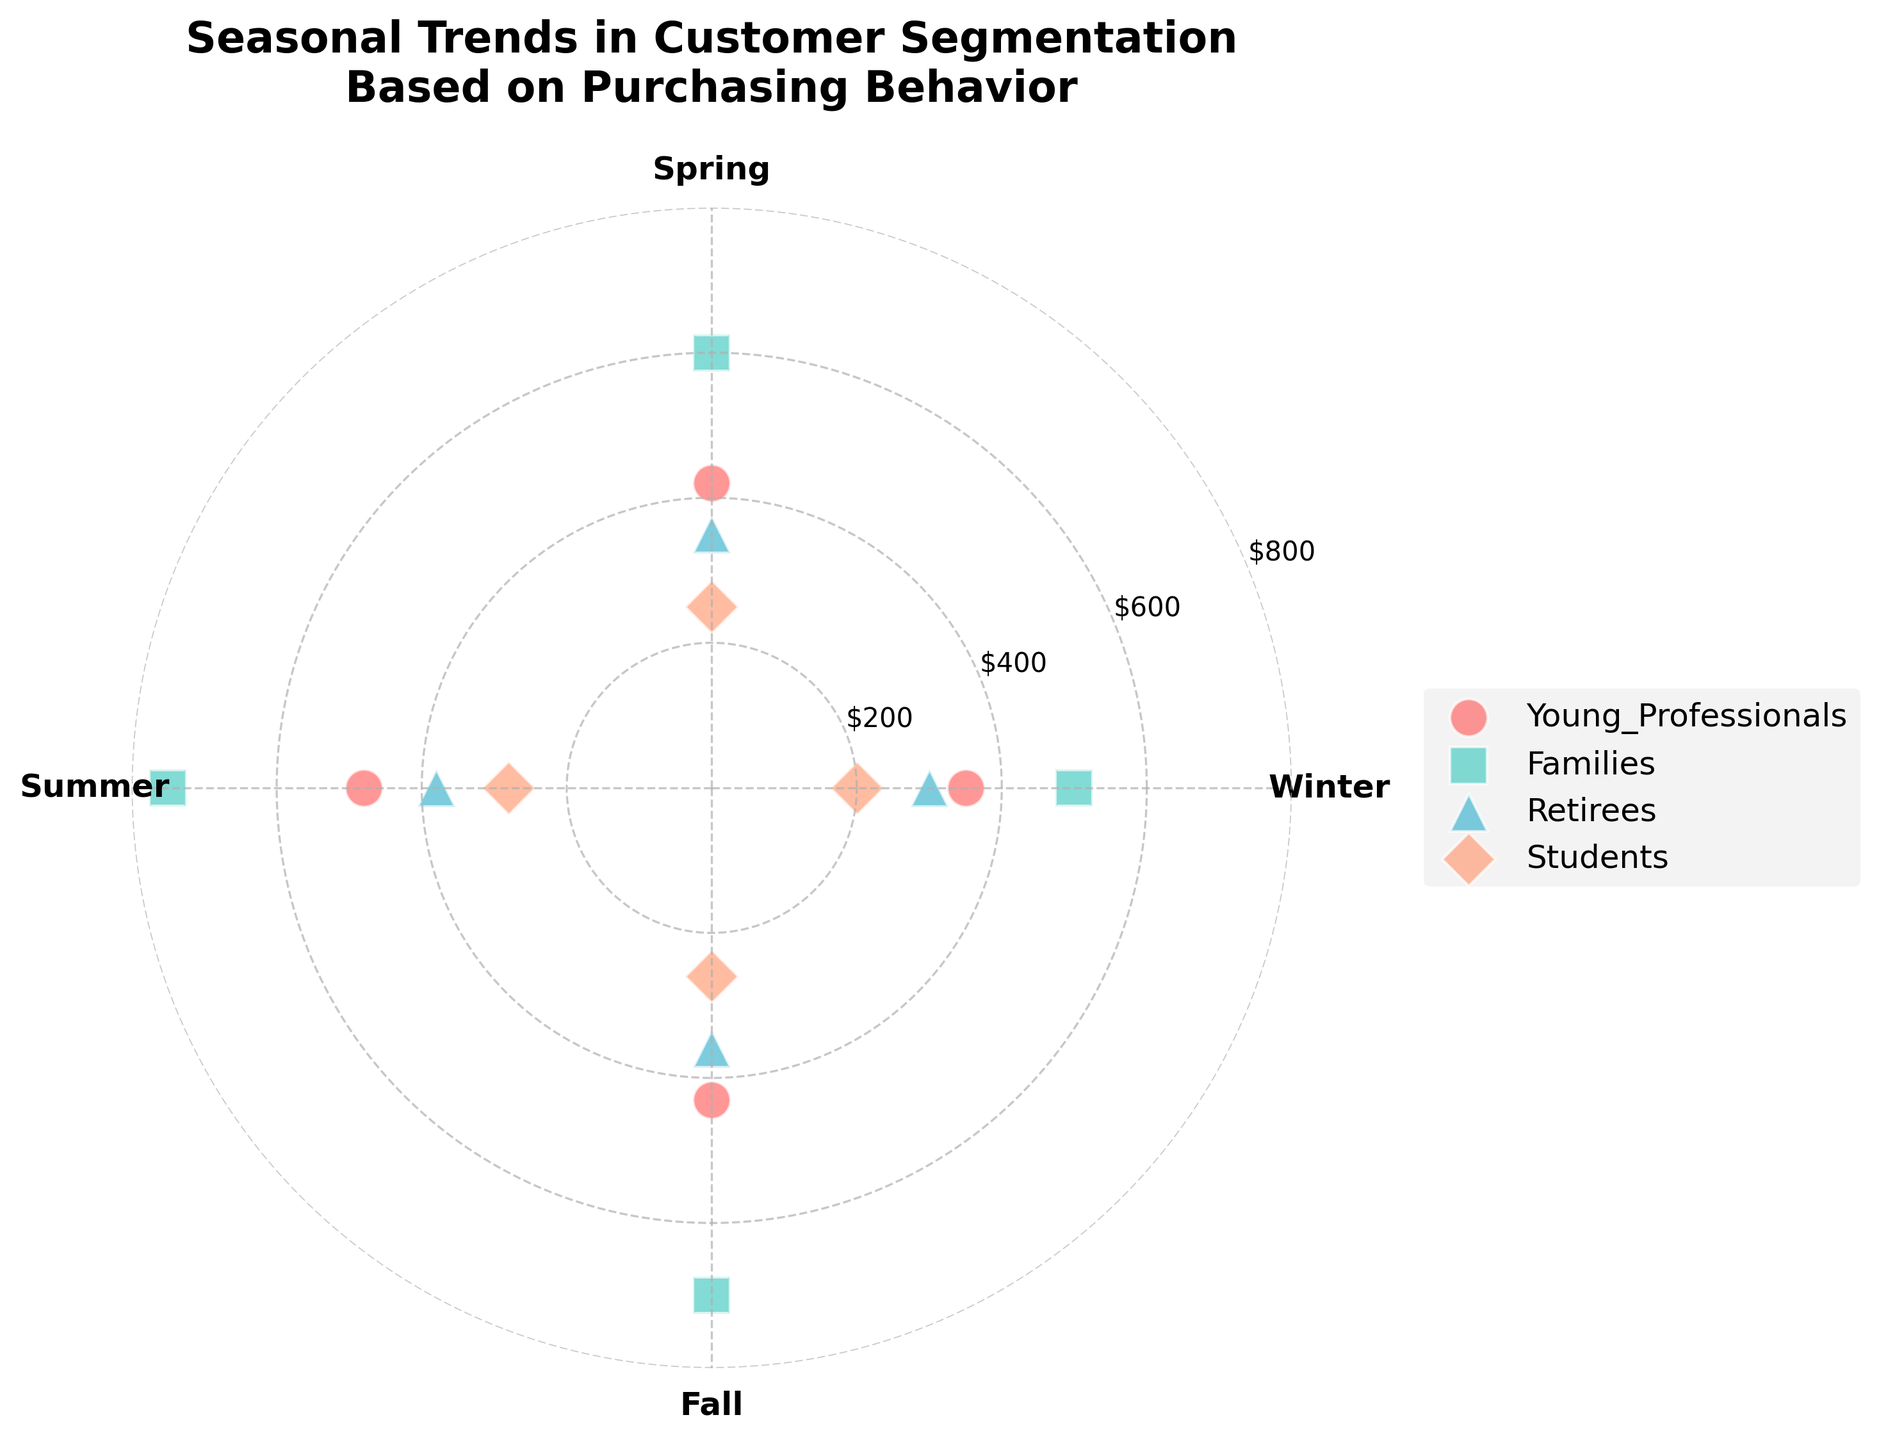What are the customer segments shown in the figure? The customer segments shown in the figure can be identified by the labels in the legend section of the plot. These are 'Young Professionals', 'Families', 'Retirees', and 'Students'.
Answer: Young Professionals, Families, Retirees, Students Which customer segment has the highest purchasing amount in Summer? By observing the radial coordinate values (purchasing amount) for each customer segment in the Summer (180 degrees), the segment with the highest value is 'Families' with a purchasing amount of 750.
Answer: Families What is the difference in purchasing amount between Families in Spring and Fall? The purchasing amount for Families in Spring is 600, and in Fall it is 700. The difference is calculated as 700 - 600 = 100.
Answer: 100 Which season has the lowest purchasing amount for Students? The purchasing amounts for Students across the seasons are: Winter 200, Spring 250, Summer 280, and Fall 260. The lowest purchasing amount is in Winter with 200.
Answer: Winter How does the purchasing behavior of Retirees change from Summer to Fall? The purchasing amount for Retirees in Summer is 380, and in Fall it is 360. The behavior shows a decrease of 20 units from Summer to Fall.
Answer: Decreases by 20 Which two customer segments show more than a 100-unit increase in purchasing amount from Winter to Summer? Comparing the difference in purchasing amounts from Winter to Summer for each customer segment: 'Young Professionals' (480 - 350 = 130), 'Families' (750 - 500 = 250), 'Retirees' (380 - 300 = 80), 'Students' (280 - 200 = 80). The segments meeting the criteria are 'Young Professionals' and 'Families'.
Answer: Young Professionals, Families What is the average purchasing amount for Young Professionals over all seasons? The purchasing amounts for Young Professionals are: Winter 350, Spring 420, Summer 480, and Fall 430. The average is calculated as (350 + 420 + 480 + 430) / 4 = 420.
Answer: 420 Which season demonstrates the highest total purchasing amount across all customer segments, and what is that amount? Summing the purchasing amounts per season across all customer segments: Winter (350+500+300+200 = 1350), Spring (420+600+350+250 = 1620), Summer (480+750+380+280 = 1890), Fall (430+700+360+260 = 1750). Summer shows the highest total purchasing amount, which is 1890.
Answer: Summer, 1890 Do any customer segments exhibit the same purchasing amount in different seasons? By examining the purchasing amounts for each customer segment across the seasons, it is noted that no segments have exactly the same purchasing amount in different seasons.
Answer: No 